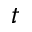<formula> <loc_0><loc_0><loc_500><loc_500>t</formula> 